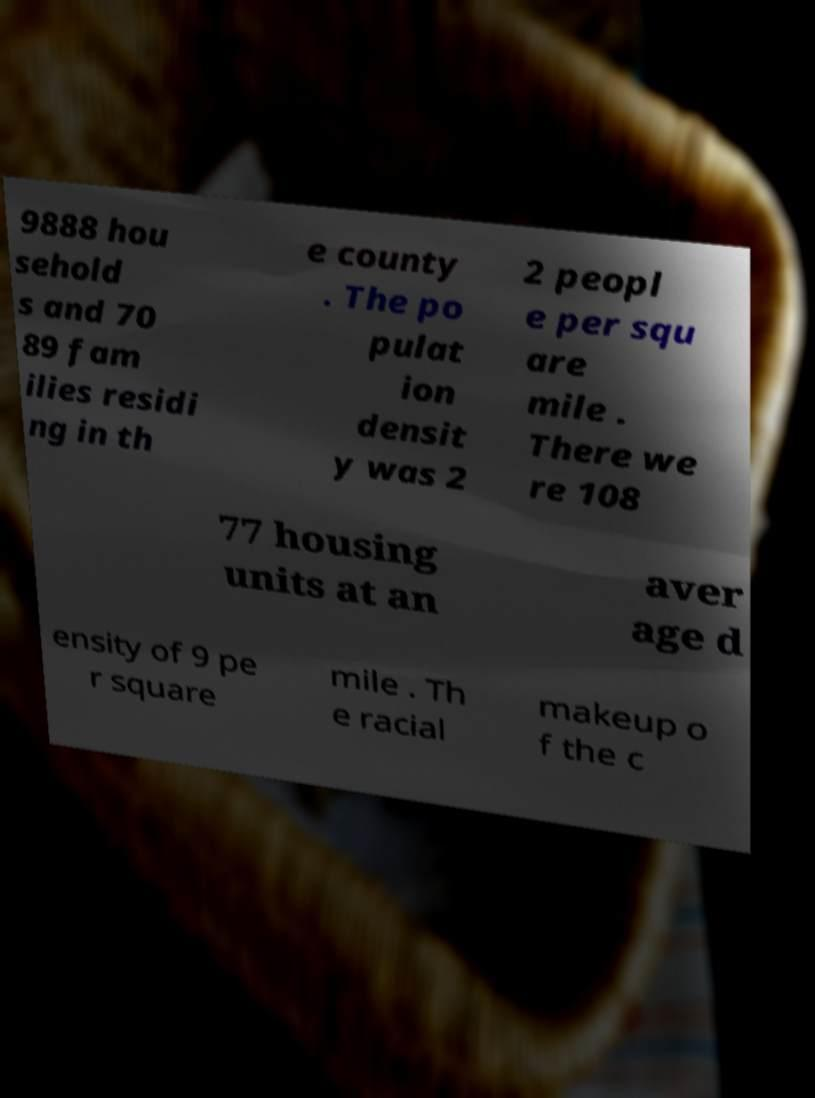There's text embedded in this image that I need extracted. Can you transcribe it verbatim? 9888 hou sehold s and 70 89 fam ilies residi ng in th e county . The po pulat ion densit y was 2 2 peopl e per squ are mile . There we re 108 77 housing units at an aver age d ensity of 9 pe r square mile . Th e racial makeup o f the c 